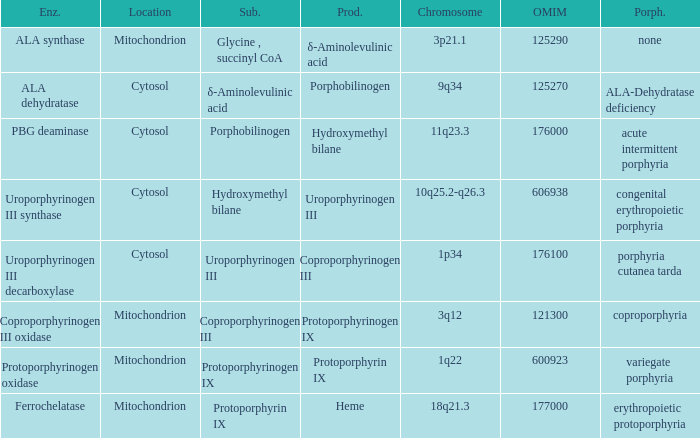What is the location of the enzyme Uroporphyrinogen iii Synthase? Cytosol. 